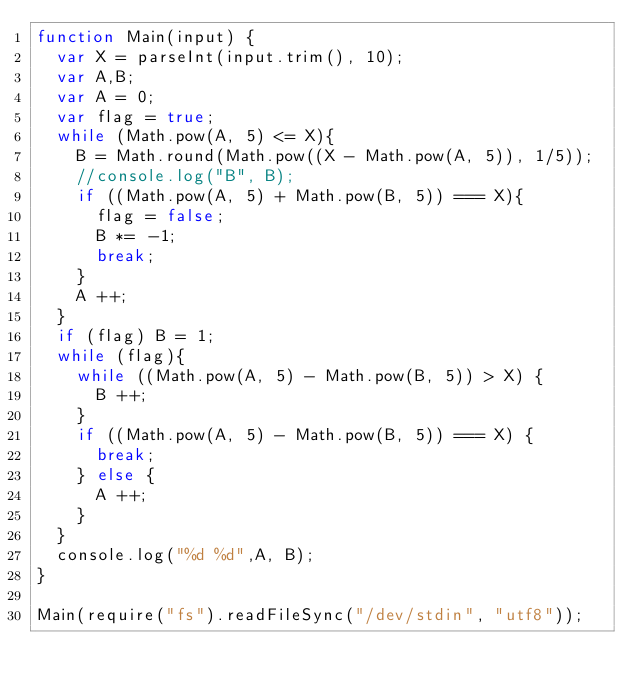Convert code to text. <code><loc_0><loc_0><loc_500><loc_500><_JavaScript_>function Main(input) {
  var X = parseInt(input.trim(), 10);
  var A,B;
  var A = 0;
  var flag = true;
  while (Math.pow(A, 5) <= X){
    B = Math.round(Math.pow((X - Math.pow(A, 5)), 1/5));
    //console.log("B", B);
    if ((Math.pow(A, 5) + Math.pow(B, 5)) === X){
      flag = false;
      B *= -1;
      break; 
    }
    A ++;
  }
  if (flag) B = 1;
  while (flag){
    while ((Math.pow(A, 5) - Math.pow(B, 5)) > X) {
      B ++;
    } 
    if ((Math.pow(A, 5) - Math.pow(B, 5)) === X) {
      break;
    } else {
      A ++;
    }
  }
  console.log("%d %d",A, B);
}   

Main(require("fs").readFileSync("/dev/stdin", "utf8"));</code> 